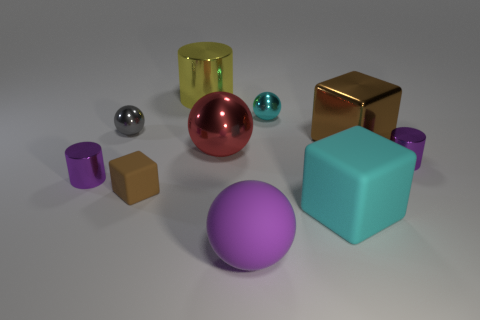Subtract 1 cubes. How many cubes are left? 2 Subtract all metal balls. How many balls are left? 1 Subtract all green spheres. Subtract all blue blocks. How many spheres are left? 4 Subtract all spheres. How many objects are left? 6 Add 8 large purple matte objects. How many large purple matte objects exist? 9 Subtract 0 yellow spheres. How many objects are left? 10 Subtract all purple rubber balls. Subtract all brown rubber objects. How many objects are left? 8 Add 1 metallic balls. How many metallic balls are left? 4 